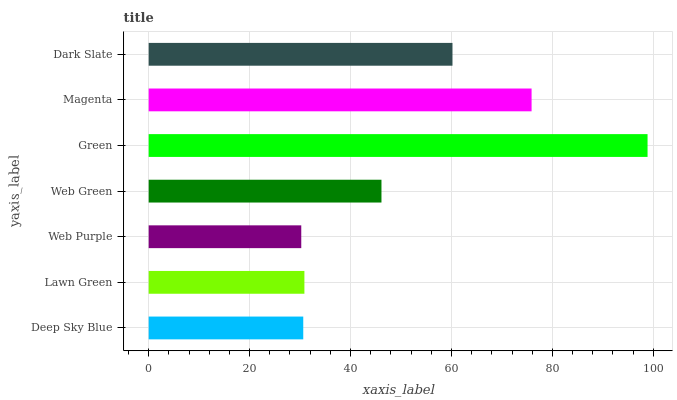Is Web Purple the minimum?
Answer yes or no. Yes. Is Green the maximum?
Answer yes or no. Yes. Is Lawn Green the minimum?
Answer yes or no. No. Is Lawn Green the maximum?
Answer yes or no. No. Is Lawn Green greater than Deep Sky Blue?
Answer yes or no. Yes. Is Deep Sky Blue less than Lawn Green?
Answer yes or no. Yes. Is Deep Sky Blue greater than Lawn Green?
Answer yes or no. No. Is Lawn Green less than Deep Sky Blue?
Answer yes or no. No. Is Web Green the high median?
Answer yes or no. Yes. Is Web Green the low median?
Answer yes or no. Yes. Is Green the high median?
Answer yes or no. No. Is Deep Sky Blue the low median?
Answer yes or no. No. 